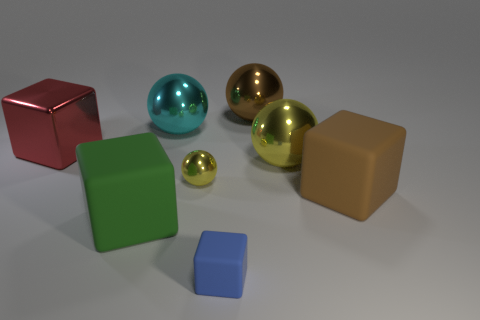There is a large rubber object to the left of the yellow ball behind the small yellow metal sphere; what is its color?
Make the answer very short. Green. What color is the tiny thing that is the same shape as the large green object?
Ensure brevity in your answer.  Blue. Is there any other thing that has the same material as the large cyan sphere?
Give a very brief answer. Yes. The brown metal thing that is the same shape as the cyan object is what size?
Provide a succinct answer. Large. There is a big ball left of the small blue matte block; what material is it?
Make the answer very short. Metal. Is the number of large brown things that are to the left of the cyan metallic object less than the number of tiny red cylinders?
Offer a terse response. No. The big brown object that is behind the shiny thing that is on the left side of the big cyan object is what shape?
Offer a terse response. Sphere. The tiny sphere is what color?
Give a very brief answer. Yellow. How many other things are there of the same size as the brown rubber thing?
Keep it short and to the point. 5. There is a large sphere that is in front of the brown metallic thing and on the right side of the big cyan sphere; what material is it?
Your response must be concise. Metal. 